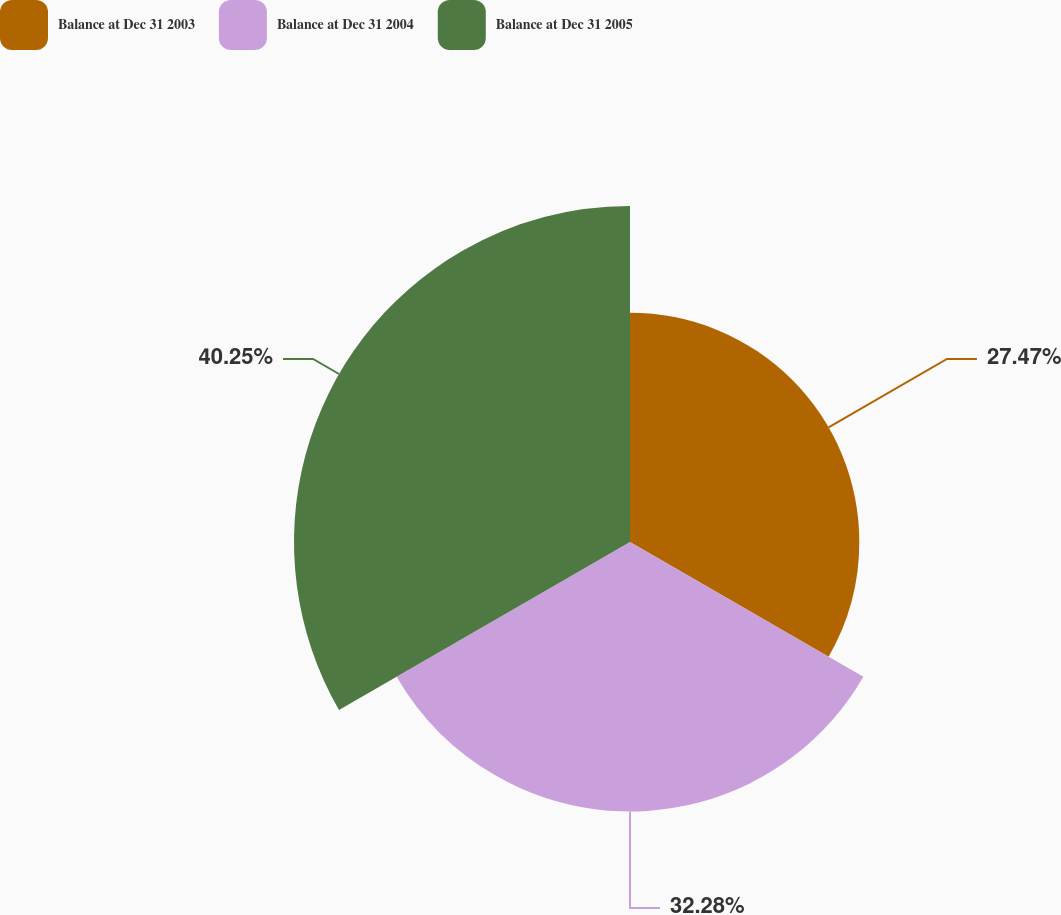Convert chart. <chart><loc_0><loc_0><loc_500><loc_500><pie_chart><fcel>Balance at Dec 31 2003<fcel>Balance at Dec 31 2004<fcel>Balance at Dec 31 2005<nl><fcel>27.47%<fcel>32.28%<fcel>40.25%<nl></chart> 